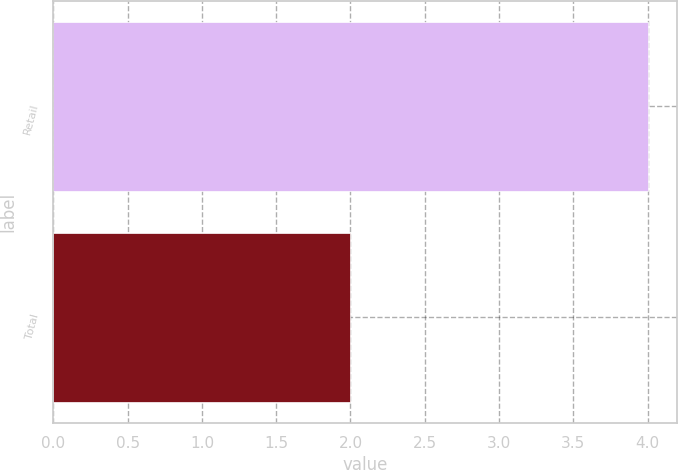<chart> <loc_0><loc_0><loc_500><loc_500><bar_chart><fcel>Retail<fcel>Total<nl><fcel>4<fcel>2<nl></chart> 